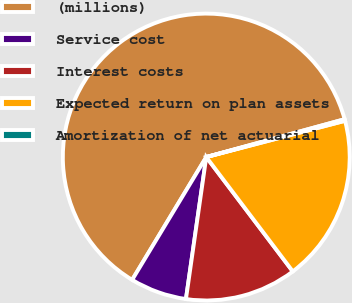Convert chart. <chart><loc_0><loc_0><loc_500><loc_500><pie_chart><fcel>(millions)<fcel>Service cost<fcel>Interest costs<fcel>Expected return on plan assets<fcel>Amortization of net actuarial<nl><fcel>62.11%<fcel>6.38%<fcel>12.57%<fcel>18.76%<fcel>0.18%<nl></chart> 